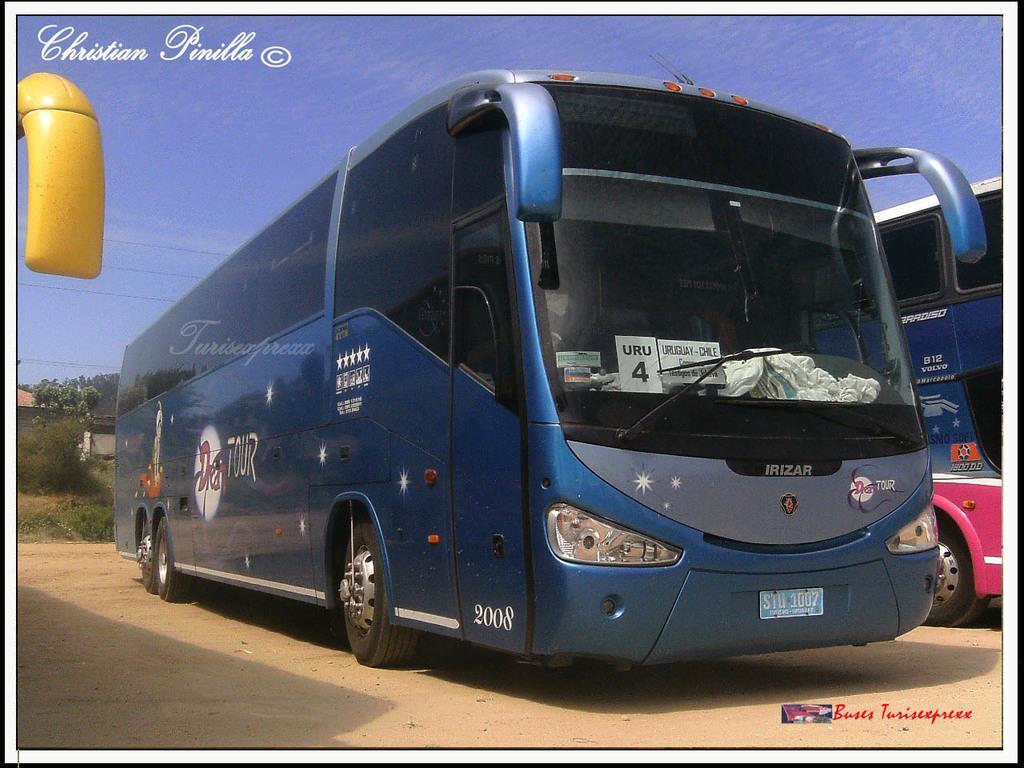Describe this image in one or two sentences. In the picture we can see a bus, which is blue in color parked on the path and beside the bus we can see another bus which is pink in color and in the background, we can see some plants to the path and trees and we can also see a sky which is blue in color and it is a photograph. 